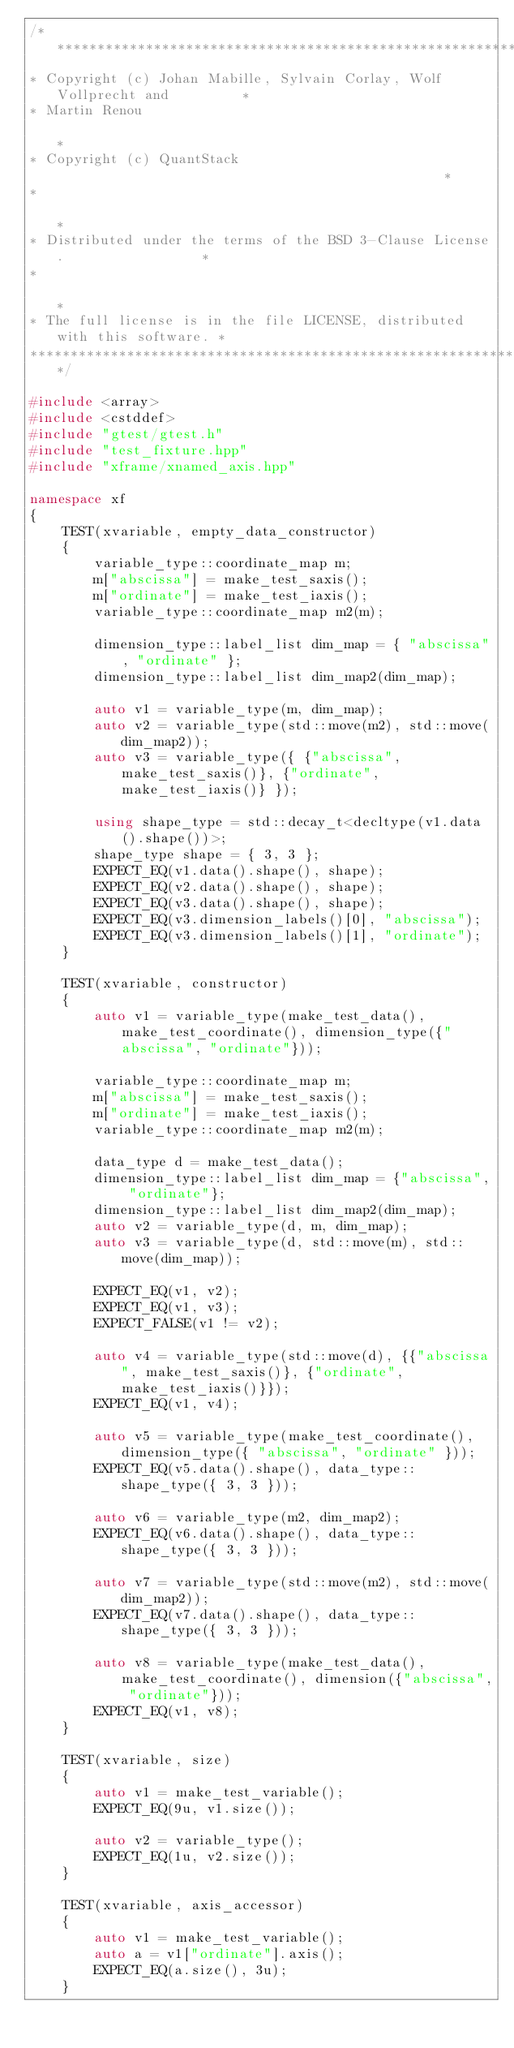<code> <loc_0><loc_0><loc_500><loc_500><_C++_>/***************************************************************************
* Copyright (c) Johan Mabille, Sylvain Corlay, Wolf Vollprecht and         *
* Martin Renou                                                             *
* Copyright (c) QuantStack                                                 *
*                                                                          *
* Distributed under the terms of the BSD 3-Clause License.                 *
*                                                                          *
* The full license is in the file LICENSE, distributed with this software. *
****************************************************************************/

#include <array>
#include <cstddef>
#include "gtest/gtest.h"
#include "test_fixture.hpp"
#include "xframe/xnamed_axis.hpp"

namespace xf
{
    TEST(xvariable, empty_data_constructor)
    {
        variable_type::coordinate_map m;
        m["abscissa"] = make_test_saxis();
        m["ordinate"] = make_test_iaxis();
        variable_type::coordinate_map m2(m);

        dimension_type::label_list dim_map = { "abscissa", "ordinate" };
        dimension_type::label_list dim_map2(dim_map);

        auto v1 = variable_type(m, dim_map);
        auto v2 = variable_type(std::move(m2), std::move(dim_map2));
        auto v3 = variable_type({ {"abscissa", make_test_saxis()}, {"ordinate", make_test_iaxis()} });

        using shape_type = std::decay_t<decltype(v1.data().shape())>;
        shape_type shape = { 3, 3 };
        EXPECT_EQ(v1.data().shape(), shape);
        EXPECT_EQ(v2.data().shape(), shape);
        EXPECT_EQ(v3.data().shape(), shape);
        EXPECT_EQ(v3.dimension_labels()[0], "abscissa");
        EXPECT_EQ(v3.dimension_labels()[1], "ordinate");
    }

    TEST(xvariable, constructor)
    {
        auto v1 = variable_type(make_test_data(), make_test_coordinate(), dimension_type({"abscissa", "ordinate"}));

        variable_type::coordinate_map m;
        m["abscissa"] = make_test_saxis();
        m["ordinate"] = make_test_iaxis();
        variable_type::coordinate_map m2(m);

        data_type d = make_test_data();
        dimension_type::label_list dim_map = {"abscissa", "ordinate"};
        dimension_type::label_list dim_map2(dim_map);
        auto v2 = variable_type(d, m, dim_map);
        auto v3 = variable_type(d, std::move(m), std::move(dim_map));

        EXPECT_EQ(v1, v2);
        EXPECT_EQ(v1, v3);
        EXPECT_FALSE(v1 != v2);

        auto v4 = variable_type(std::move(d), {{"abscissa", make_test_saxis()}, {"ordinate", make_test_iaxis()}});
        EXPECT_EQ(v1, v4);

        auto v5 = variable_type(make_test_coordinate(), dimension_type({ "abscissa", "ordinate" }));
        EXPECT_EQ(v5.data().shape(), data_type::shape_type({ 3, 3 }));

        auto v6 = variable_type(m2, dim_map2);
        EXPECT_EQ(v6.data().shape(), data_type::shape_type({ 3, 3 }));

        auto v7 = variable_type(std::move(m2), std::move(dim_map2));
        EXPECT_EQ(v7.data().shape(), data_type::shape_type({ 3, 3 }));

        auto v8 = variable_type(make_test_data(), make_test_coordinate(), dimension({"abscissa", "ordinate"}));
        EXPECT_EQ(v1, v8);
    }

    TEST(xvariable, size)
    {
        auto v1 = make_test_variable();
        EXPECT_EQ(9u, v1.size());

        auto v2 = variable_type();
        EXPECT_EQ(1u, v2.size());
    }

    TEST(xvariable, axis_accessor)
    {
        auto v1 = make_test_variable();
        auto a = v1["ordinate"].axis();
        EXPECT_EQ(a.size(), 3u);
    }
</code> 